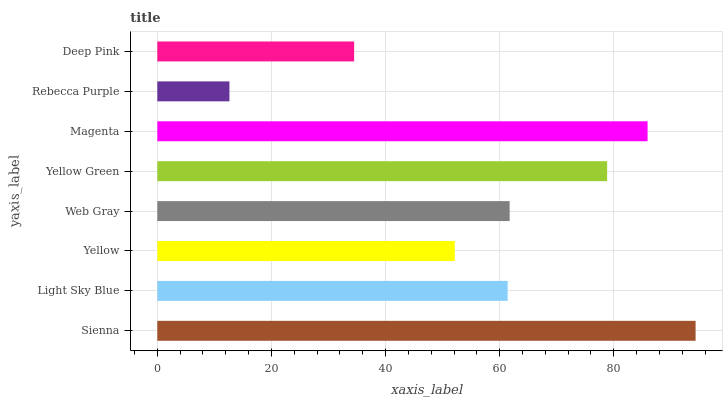Is Rebecca Purple the minimum?
Answer yes or no. Yes. Is Sienna the maximum?
Answer yes or no. Yes. Is Light Sky Blue the minimum?
Answer yes or no. No. Is Light Sky Blue the maximum?
Answer yes or no. No. Is Sienna greater than Light Sky Blue?
Answer yes or no. Yes. Is Light Sky Blue less than Sienna?
Answer yes or no. Yes. Is Light Sky Blue greater than Sienna?
Answer yes or no. No. Is Sienna less than Light Sky Blue?
Answer yes or no. No. Is Web Gray the high median?
Answer yes or no. Yes. Is Light Sky Blue the low median?
Answer yes or no. Yes. Is Light Sky Blue the high median?
Answer yes or no. No. Is Yellow Green the low median?
Answer yes or no. No. 